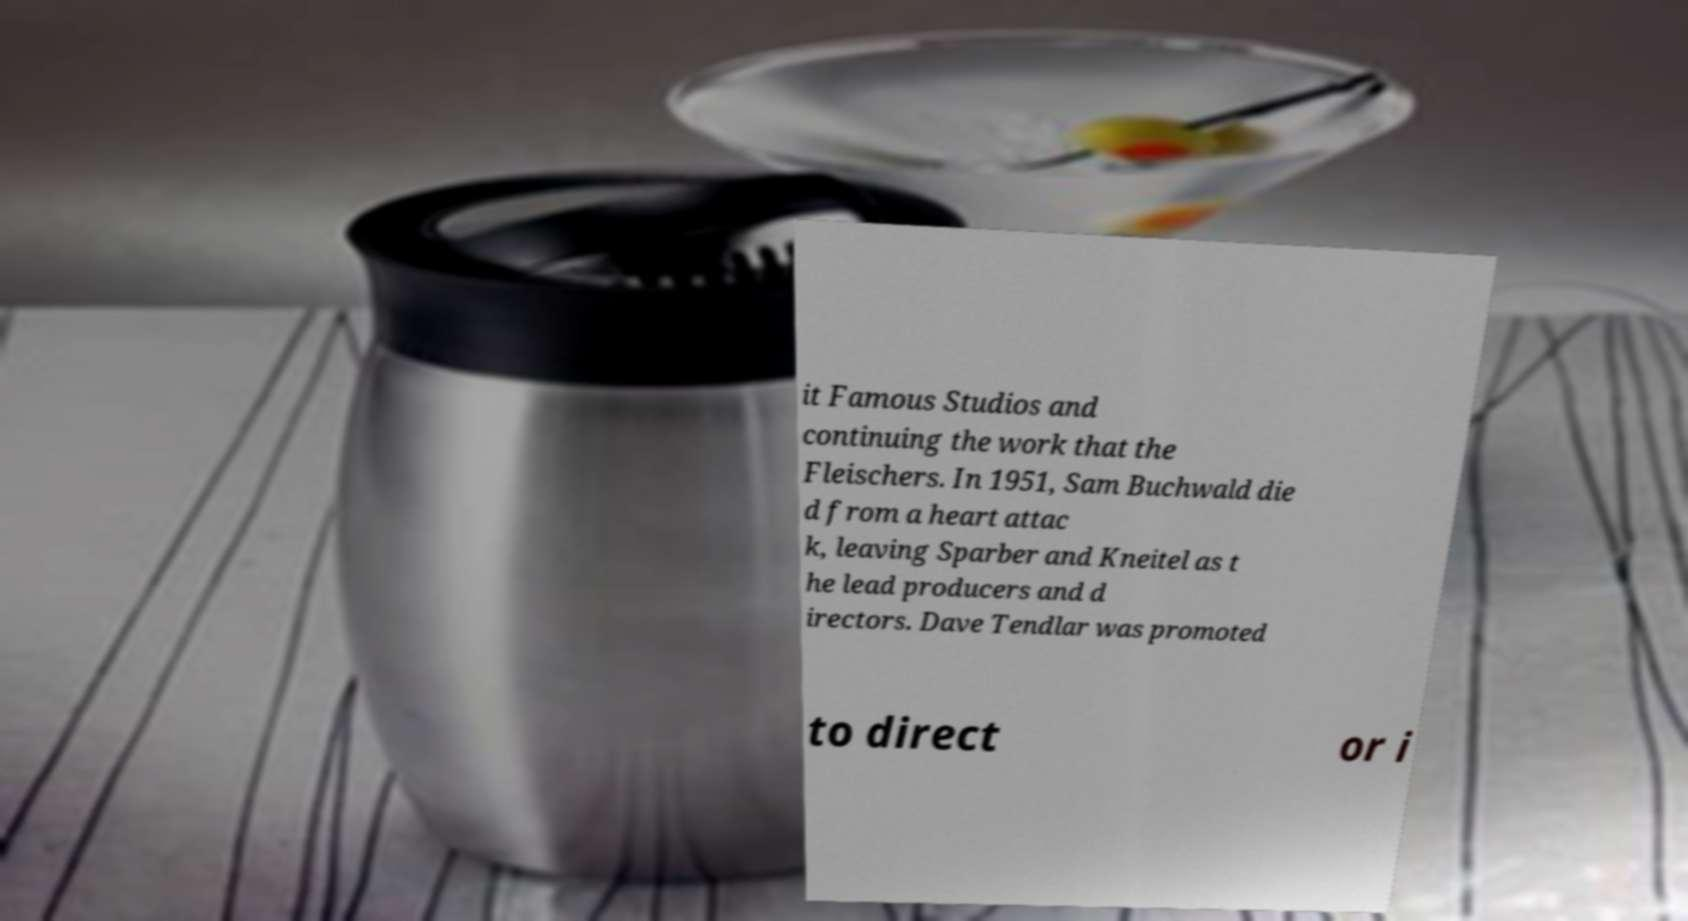Can you accurately transcribe the text from the provided image for me? it Famous Studios and continuing the work that the Fleischers. In 1951, Sam Buchwald die d from a heart attac k, leaving Sparber and Kneitel as t he lead producers and d irectors. Dave Tendlar was promoted to direct or i 